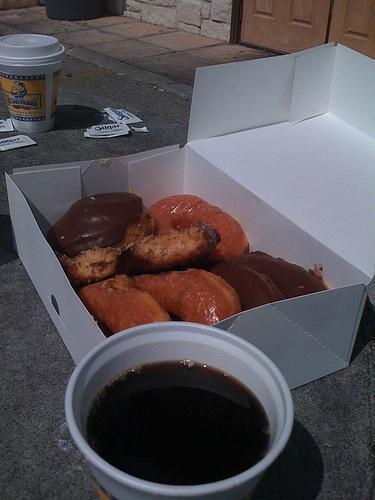How many cups can be seen?
Give a very brief answer. 2. How many donuts are in the picture?
Give a very brief answer. 5. 